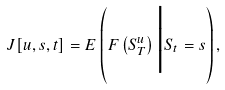<formula> <loc_0><loc_0><loc_500><loc_500>J [ u , s , t ] = E \left ( F \left ( S ^ { u } _ { T } \right ) \Big | S _ { t } = s \right ) ,</formula> 